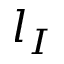Convert formula to latex. <formula><loc_0><loc_0><loc_500><loc_500>l _ { I }</formula> 